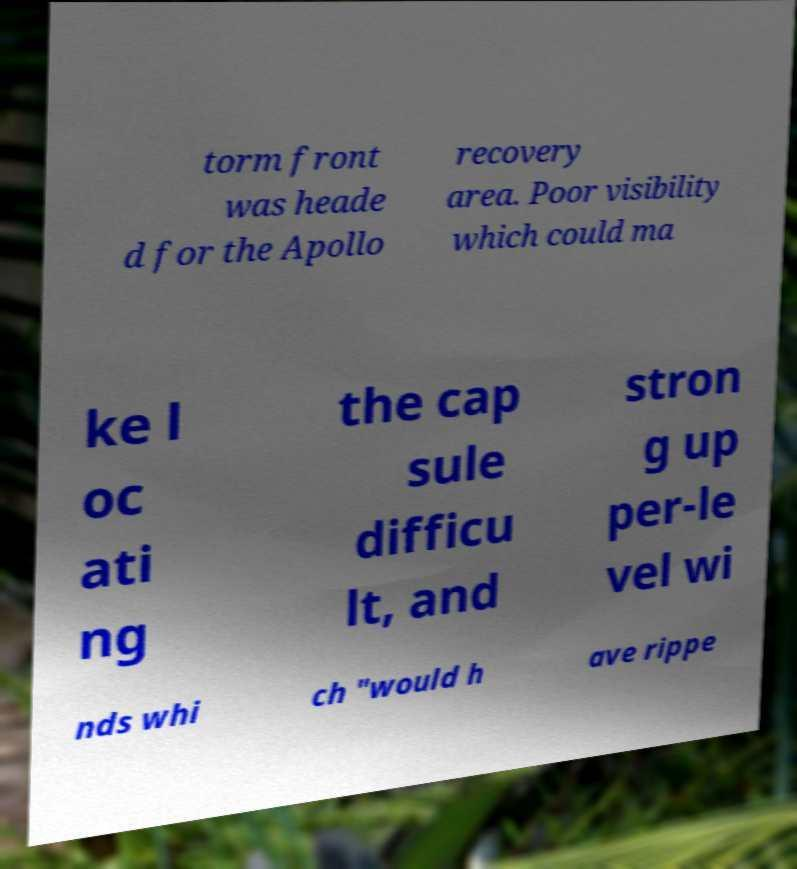What messages or text are displayed in this image? I need them in a readable, typed format. torm front was heade d for the Apollo recovery area. Poor visibility which could ma ke l oc ati ng the cap sule difficu lt, and stron g up per-le vel wi nds whi ch "would h ave rippe 